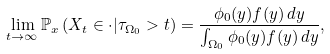<formula> <loc_0><loc_0><loc_500><loc_500>\lim _ { t \rightarrow \infty } \mathbb { P } _ { x } \left ( X _ { t } \in \cdot | \tau _ { \Omega _ { 0 } } > t \right ) = \frac { \phi _ { 0 } ( y ) f ( y ) \, d y } { \int _ { \Omega _ { 0 } } \phi _ { 0 } ( y ) f ( y ) \, d y } ,</formula> 